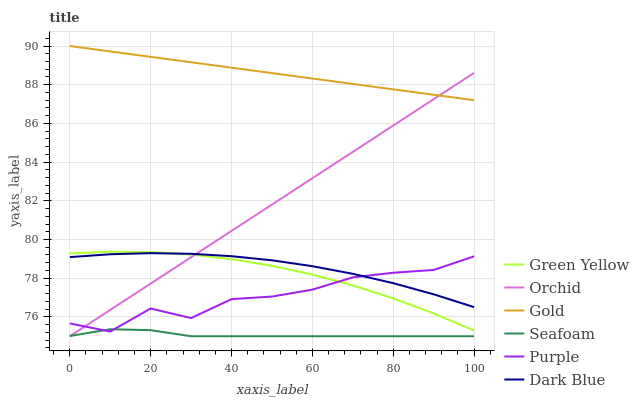Does Purple have the minimum area under the curve?
Answer yes or no. No. Does Purple have the maximum area under the curve?
Answer yes or no. No. Is Seafoam the smoothest?
Answer yes or no. No. Is Seafoam the roughest?
Answer yes or no. No. Does Purple have the lowest value?
Answer yes or no. No. Does Purple have the highest value?
Answer yes or no. No. Is Green Yellow less than Gold?
Answer yes or no. Yes. Is Dark Blue greater than Seafoam?
Answer yes or no. Yes. Does Green Yellow intersect Gold?
Answer yes or no. No. 